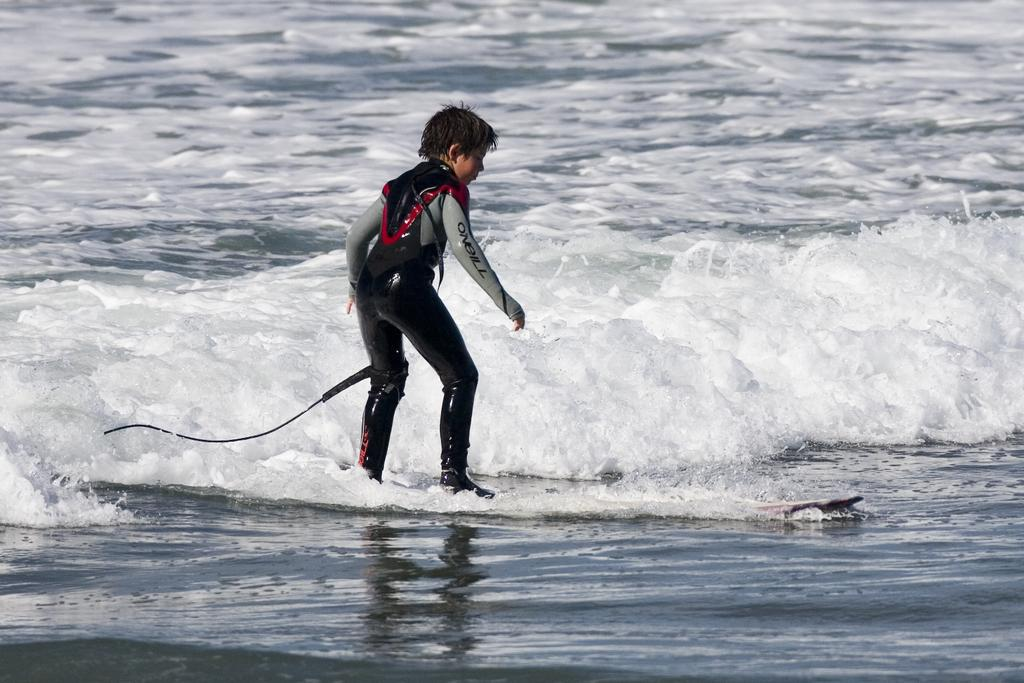<image>
Write a terse but informative summary of the picture. The surfer is wearing a wetsuit by Oneill. 